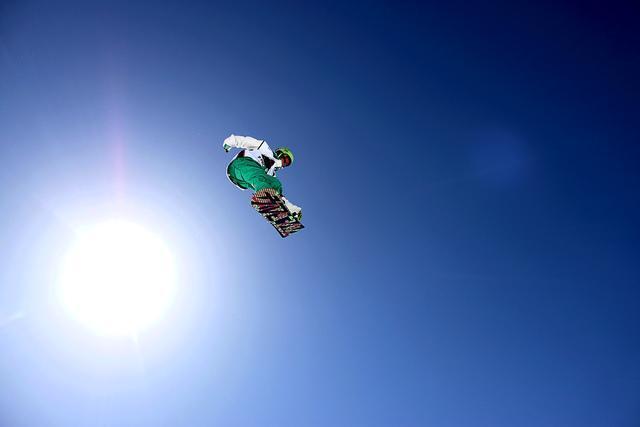How many people are there?
Give a very brief answer. 1. How many windows are on the train in the picture?
Give a very brief answer. 0. 